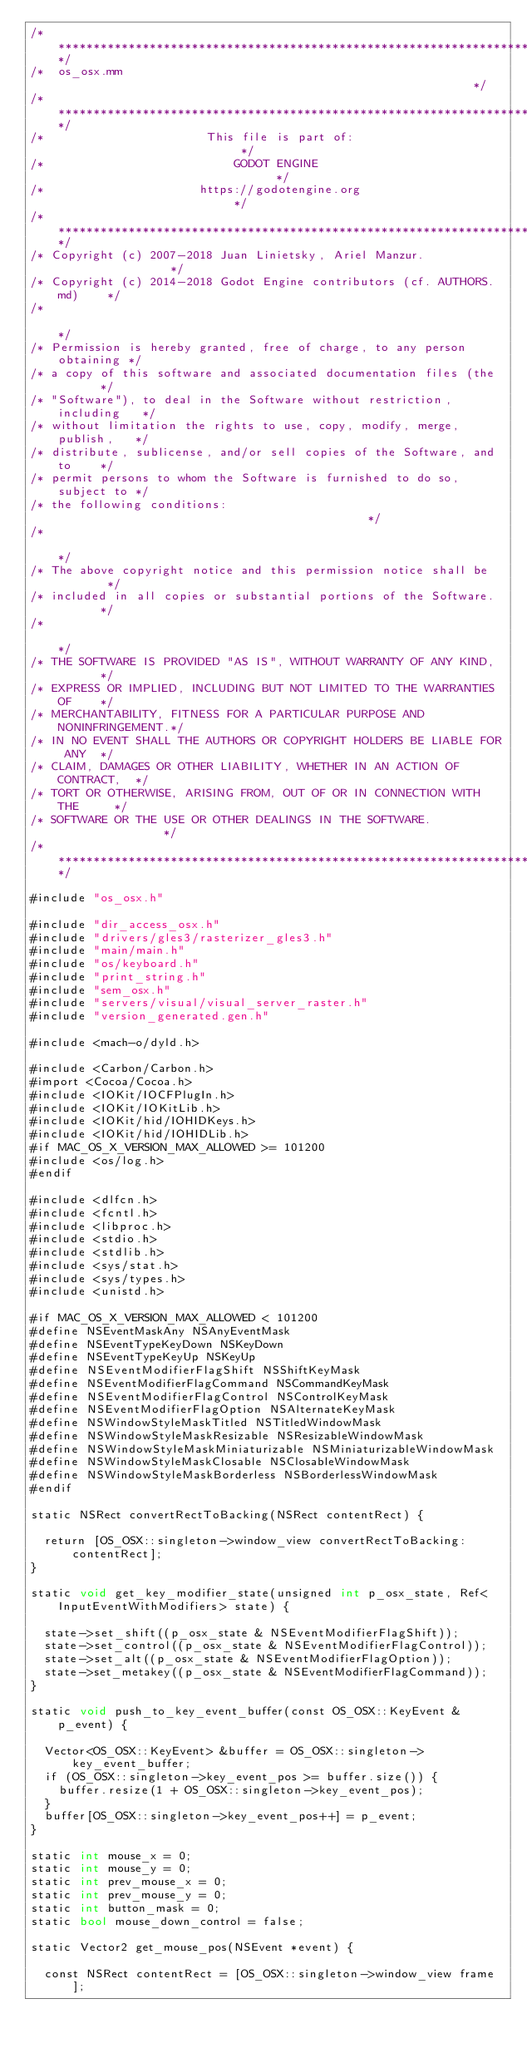<code> <loc_0><loc_0><loc_500><loc_500><_ObjectiveC_>/*************************************************************************/
/*  os_osx.mm                                                            */
/*************************************************************************/
/*                       This file is part of:                           */
/*                           GODOT ENGINE                                */
/*                      https://godotengine.org                          */
/*************************************************************************/
/* Copyright (c) 2007-2018 Juan Linietsky, Ariel Manzur.                 */
/* Copyright (c) 2014-2018 Godot Engine contributors (cf. AUTHORS.md)    */
/*                                                                       */
/* Permission is hereby granted, free of charge, to any person obtaining */
/* a copy of this software and associated documentation files (the       */
/* "Software"), to deal in the Software without restriction, including   */
/* without limitation the rights to use, copy, modify, merge, publish,   */
/* distribute, sublicense, and/or sell copies of the Software, and to    */
/* permit persons to whom the Software is furnished to do so, subject to */
/* the following conditions:                                             */
/*                                                                       */
/* The above copyright notice and this permission notice shall be        */
/* included in all copies or substantial portions of the Software.       */
/*                                                                       */
/* THE SOFTWARE IS PROVIDED "AS IS", WITHOUT WARRANTY OF ANY KIND,       */
/* EXPRESS OR IMPLIED, INCLUDING BUT NOT LIMITED TO THE WARRANTIES OF    */
/* MERCHANTABILITY, FITNESS FOR A PARTICULAR PURPOSE AND NONINFRINGEMENT.*/
/* IN NO EVENT SHALL THE AUTHORS OR COPYRIGHT HOLDERS BE LIABLE FOR ANY  */
/* CLAIM, DAMAGES OR OTHER LIABILITY, WHETHER IN AN ACTION OF CONTRACT,  */
/* TORT OR OTHERWISE, ARISING FROM, OUT OF OR IN CONNECTION WITH THE     */
/* SOFTWARE OR THE USE OR OTHER DEALINGS IN THE SOFTWARE.                */
/*************************************************************************/

#include "os_osx.h"

#include "dir_access_osx.h"
#include "drivers/gles3/rasterizer_gles3.h"
#include "main/main.h"
#include "os/keyboard.h"
#include "print_string.h"
#include "sem_osx.h"
#include "servers/visual/visual_server_raster.h"
#include "version_generated.gen.h"

#include <mach-o/dyld.h>

#include <Carbon/Carbon.h>
#import <Cocoa/Cocoa.h>
#include <IOKit/IOCFPlugIn.h>
#include <IOKit/IOKitLib.h>
#include <IOKit/hid/IOHIDKeys.h>
#include <IOKit/hid/IOHIDLib.h>
#if MAC_OS_X_VERSION_MAX_ALLOWED >= 101200
#include <os/log.h>
#endif

#include <dlfcn.h>
#include <fcntl.h>
#include <libproc.h>
#include <stdio.h>
#include <stdlib.h>
#include <sys/stat.h>
#include <sys/types.h>
#include <unistd.h>

#if MAC_OS_X_VERSION_MAX_ALLOWED < 101200
#define NSEventMaskAny NSAnyEventMask
#define NSEventTypeKeyDown NSKeyDown
#define NSEventTypeKeyUp NSKeyUp
#define NSEventModifierFlagShift NSShiftKeyMask
#define NSEventModifierFlagCommand NSCommandKeyMask
#define NSEventModifierFlagControl NSControlKeyMask
#define NSEventModifierFlagOption NSAlternateKeyMask
#define NSWindowStyleMaskTitled NSTitledWindowMask
#define NSWindowStyleMaskResizable NSResizableWindowMask
#define NSWindowStyleMaskMiniaturizable NSMiniaturizableWindowMask
#define NSWindowStyleMaskClosable NSClosableWindowMask
#define NSWindowStyleMaskBorderless NSBorderlessWindowMask
#endif

static NSRect convertRectToBacking(NSRect contentRect) {

	return [OS_OSX::singleton->window_view convertRectToBacking:contentRect];
}

static void get_key_modifier_state(unsigned int p_osx_state, Ref<InputEventWithModifiers> state) {

	state->set_shift((p_osx_state & NSEventModifierFlagShift));
	state->set_control((p_osx_state & NSEventModifierFlagControl));
	state->set_alt((p_osx_state & NSEventModifierFlagOption));
	state->set_metakey((p_osx_state & NSEventModifierFlagCommand));
}

static void push_to_key_event_buffer(const OS_OSX::KeyEvent &p_event) {

	Vector<OS_OSX::KeyEvent> &buffer = OS_OSX::singleton->key_event_buffer;
	if (OS_OSX::singleton->key_event_pos >= buffer.size()) {
		buffer.resize(1 + OS_OSX::singleton->key_event_pos);
	}
	buffer[OS_OSX::singleton->key_event_pos++] = p_event;
}

static int mouse_x = 0;
static int mouse_y = 0;
static int prev_mouse_x = 0;
static int prev_mouse_y = 0;
static int button_mask = 0;
static bool mouse_down_control = false;

static Vector2 get_mouse_pos(NSEvent *event) {

	const NSRect contentRect = [OS_OSX::singleton->window_view frame];</code> 